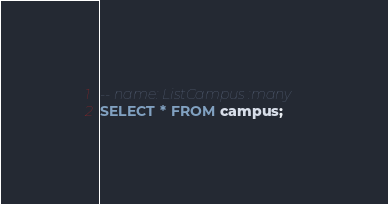<code> <loc_0><loc_0><loc_500><loc_500><_SQL_>-- name: ListCampus :many
SELECT * FROM campus;
</code> 